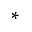<formula> <loc_0><loc_0><loc_500><loc_500>^ { \ast }</formula> 